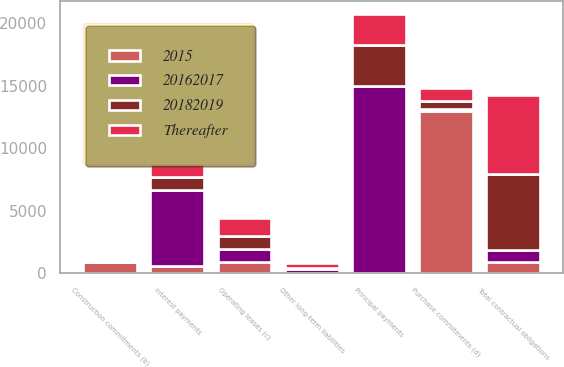<chart> <loc_0><loc_0><loc_500><loc_500><stacked_bar_chart><ecel><fcel>Principal payments<fcel>Interest payments<fcel>Construction commitments (b)<fcel>Operating leases (c)<fcel>Purchase commitments (d)<fcel>Other long-term liabilities<fcel>Total contractual obligations<nl><fcel>2015<fcel>0<fcel>566<fcel>880<fcel>878<fcel>12995<fcel>0<fcel>924.5<nl><fcel>Thereafter<fcel>2500<fcel>1069<fcel>0<fcel>1419<fcel>969<fcel>354<fcel>6311<nl><fcel>20182019<fcel>3300<fcel>1015<fcel>0<fcel>1054<fcel>657<fcel>80<fcel>6106<nl><fcel>20162017<fcel>14945<fcel>6110<fcel>0<fcel>1063<fcel>153<fcel>393<fcel>924.5<nl></chart> 